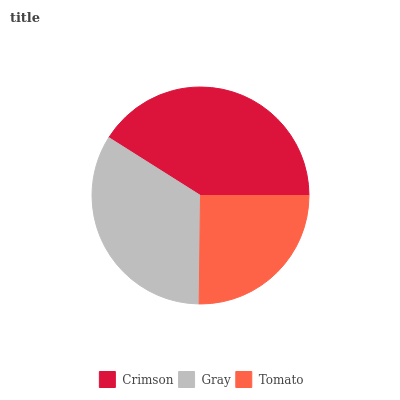Is Tomato the minimum?
Answer yes or no. Yes. Is Crimson the maximum?
Answer yes or no. Yes. Is Gray the minimum?
Answer yes or no. No. Is Gray the maximum?
Answer yes or no. No. Is Crimson greater than Gray?
Answer yes or no. Yes. Is Gray less than Crimson?
Answer yes or no. Yes. Is Gray greater than Crimson?
Answer yes or no. No. Is Crimson less than Gray?
Answer yes or no. No. Is Gray the high median?
Answer yes or no. Yes. Is Gray the low median?
Answer yes or no. Yes. Is Tomato the high median?
Answer yes or no. No. Is Tomato the low median?
Answer yes or no. No. 